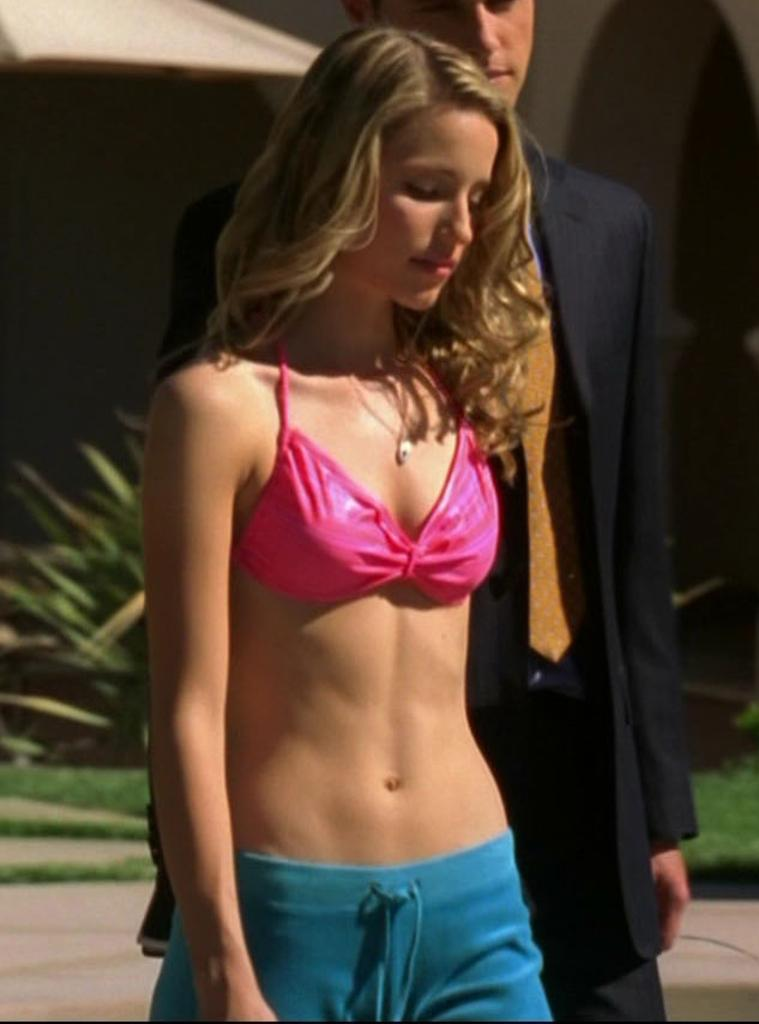Who are the people in the image? There is a girl and a man in the image. What are the girl and the man doing in the image? The girl and the man are standing in the image. What object is present to provide shelter from the elements? There is an umbrella in the image. What type of vegetation can be seen in the image? There are plants in the image. What is the ground covered with in the image? The ground is covered with grass in the image. How is the man dressed in the image? The man is wearing a coat and tie in the image. Is there a heat source visible in the image? There is no heat source visible in the image. Does the existence of the girl and the man in the image prove the existence of life on other planets? The existence of the girl and the man in the image does not prove the existence of life on other planets, as it only shows two individuals on Earth. 